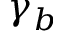Convert formula to latex. <formula><loc_0><loc_0><loc_500><loc_500>\gamma _ { b }</formula> 